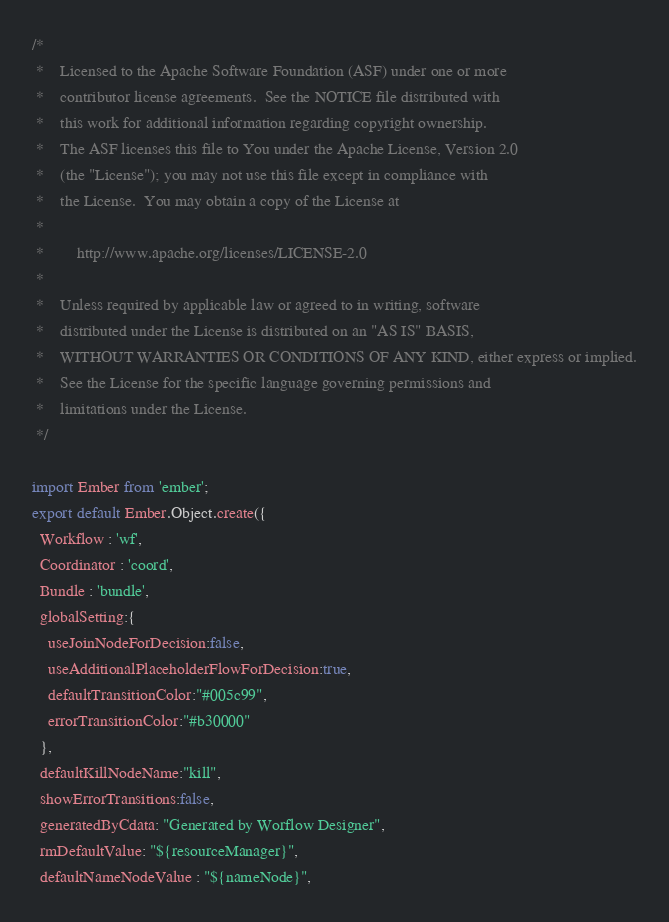<code> <loc_0><loc_0><loc_500><loc_500><_JavaScript_>/*
 *    Licensed to the Apache Software Foundation (ASF) under one or more
 *    contributor license agreements.  See the NOTICE file distributed with
 *    this work for additional information regarding copyright ownership.
 *    The ASF licenses this file to You under the Apache License, Version 2.0
 *    (the "License"); you may not use this file except in compliance with
 *    the License.  You may obtain a copy of the License at
 *
 *        http://www.apache.org/licenses/LICENSE-2.0
 *
 *    Unless required by applicable law or agreed to in writing, software
 *    distributed under the License is distributed on an "AS IS" BASIS,
 *    WITHOUT WARRANTIES OR CONDITIONS OF ANY KIND, either express or implied.
 *    See the License for the specific language governing permissions and
 *    limitations under the License.
 */

import Ember from 'ember';
export default Ember.Object.create({
  Workflow : 'wf',
  Coordinator : 'coord',
  Bundle : 'bundle',
  globalSetting:{
    useJoinNodeForDecision:false,
    useAdditionalPlaceholderFlowForDecision:true,
    defaultTransitionColor:"#005c99",
    errorTransitionColor:"#b30000"
  },
  defaultKillNodeName:"kill",
  showErrorTransitions:false,
  generatedByCdata: "Generated by Worflow Designer",
  rmDefaultValue: "${resourceManager}",
  defaultNameNodeValue : "${nameNode}",</code> 